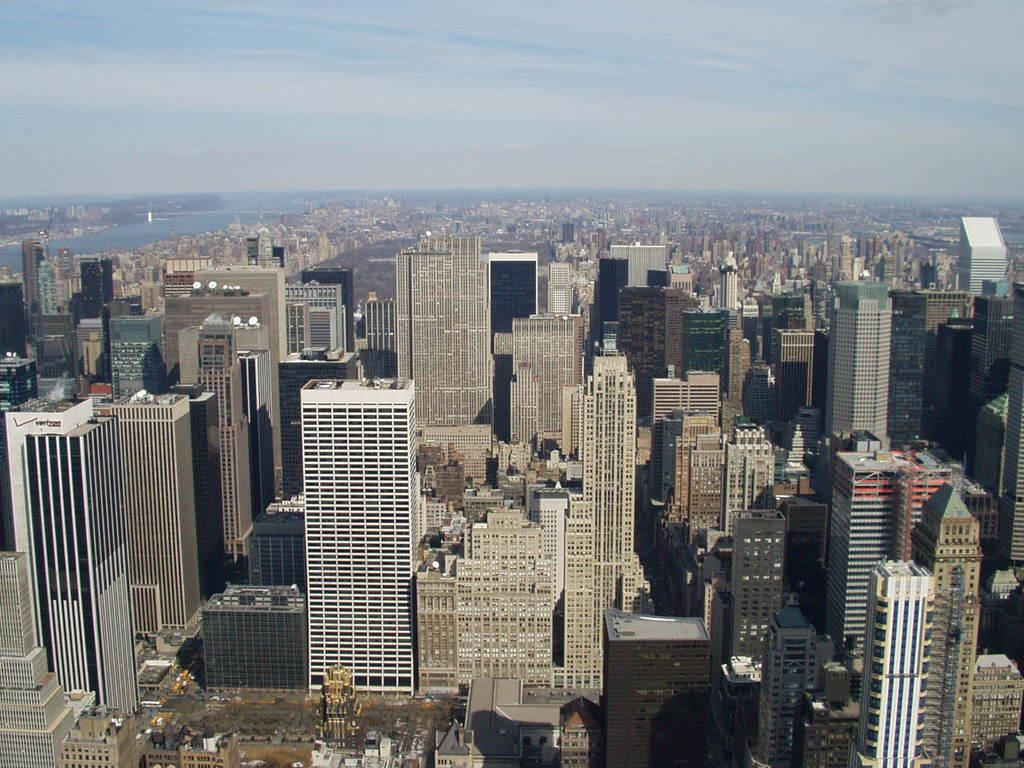What perspective is used to capture the image? The image is taken from a top view. What type of structures can be seen in the image? There are many buildings and skyscrapers in the image. What natural element is visible on the left side of the image? There is water visible on the left side of the image. What is visible at the top of the image? The sky is visible at the top of the image. What is the title of the book shown on the table in the image? There is no book or table present in the image; it primarily features buildings, skyscrapers, water, and the sky. What type of rock can be seen on the right side of the image? There is no rock visible in the image; it mainly consists of buildings, skyscrapers, water, and the sky. 